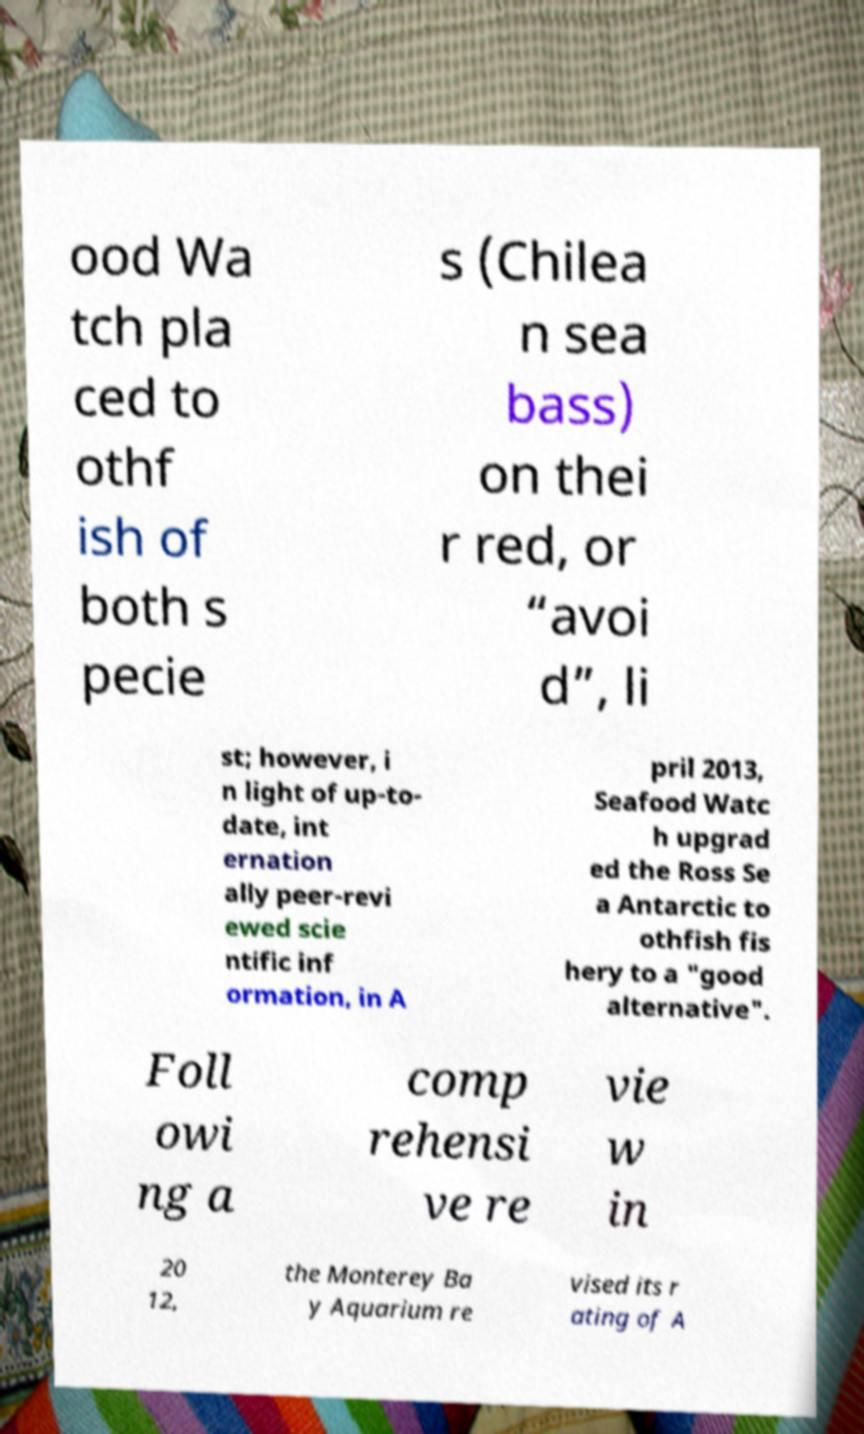There's text embedded in this image that I need extracted. Can you transcribe it verbatim? ood Wa tch pla ced to othf ish of both s pecie s (Chilea n sea bass) on thei r red, or “avoi d”, li st; however, i n light of up-to- date, int ernation ally peer-revi ewed scie ntific inf ormation, in A pril 2013, Seafood Watc h upgrad ed the Ross Se a Antarctic to othfish fis hery to a "good alternative". Foll owi ng a comp rehensi ve re vie w in 20 12, the Monterey Ba y Aquarium re vised its r ating of A 